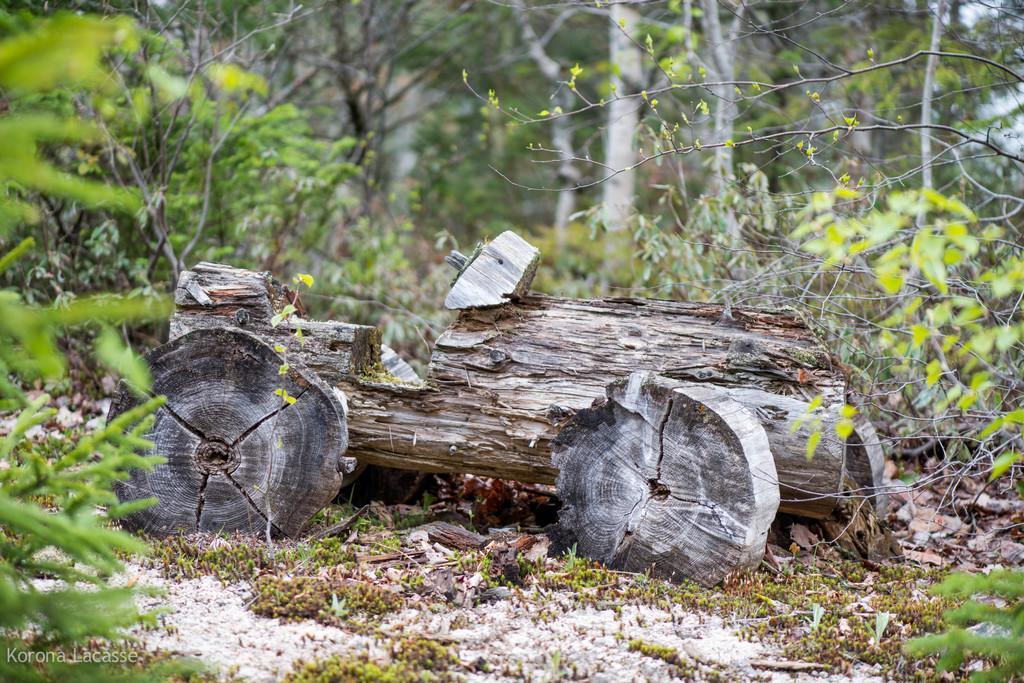How would you summarize this image in a sentence or two? In this image I can see a trunk and few green color trees around. 